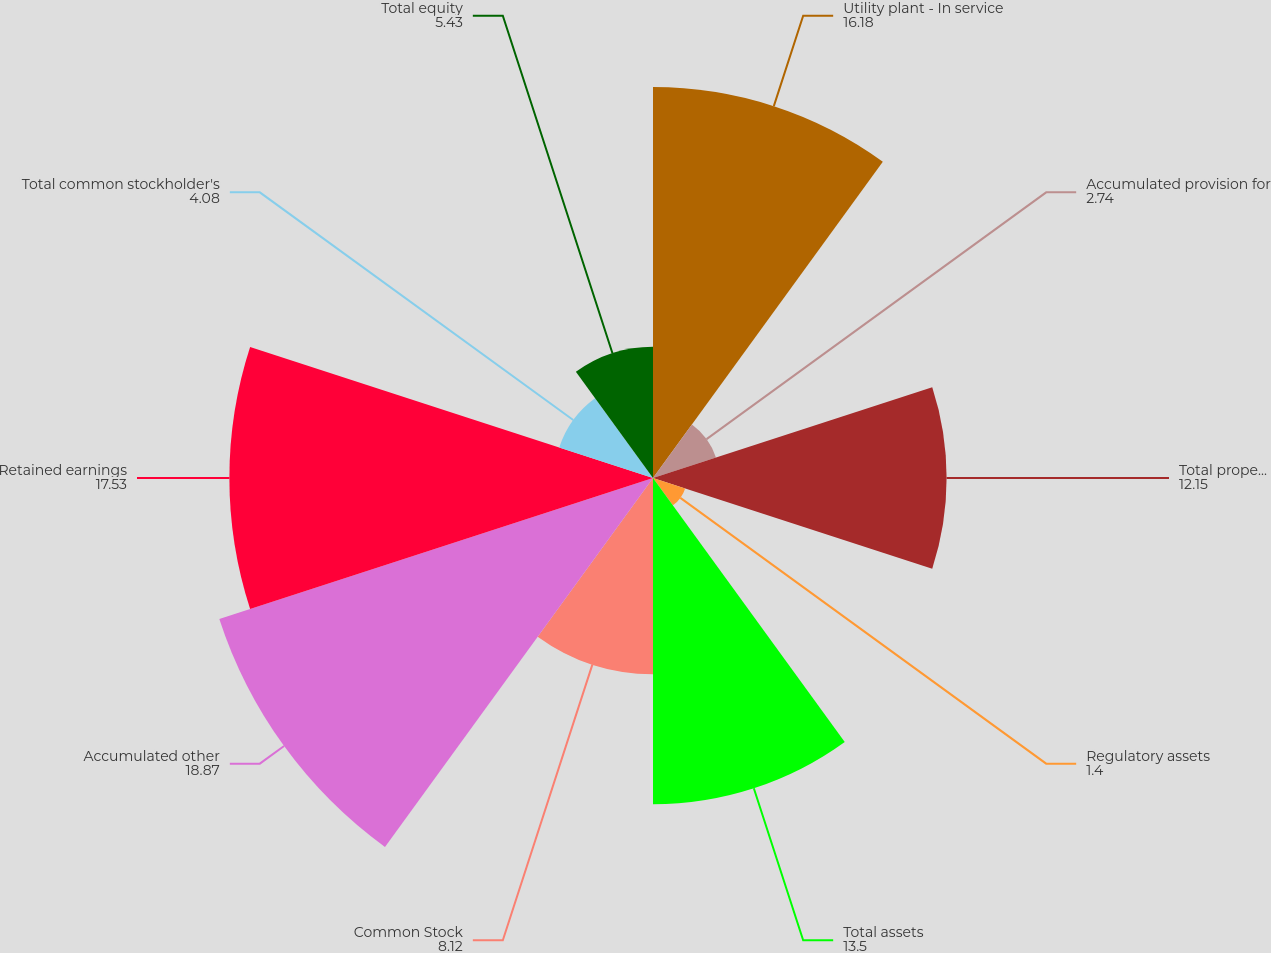Convert chart to OTSL. <chart><loc_0><loc_0><loc_500><loc_500><pie_chart><fcel>Utility plant - In service<fcel>Accumulated provision for<fcel>Total property plant and<fcel>Regulatory assets<fcel>Total assets<fcel>Common Stock<fcel>Accumulated other<fcel>Retained earnings<fcel>Total common stockholder's<fcel>Total equity<nl><fcel>16.18%<fcel>2.74%<fcel>12.15%<fcel>1.4%<fcel>13.5%<fcel>8.12%<fcel>18.87%<fcel>17.53%<fcel>4.08%<fcel>5.43%<nl></chart> 